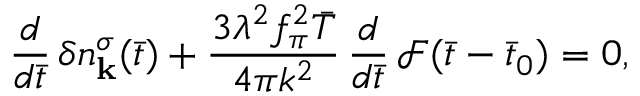Convert formula to latex. <formula><loc_0><loc_0><loc_500><loc_500>\frac { d } { d \bar { t } } \, \delta n _ { k } ^ { \sigma } ( \bar { t } ) + \frac { 3 \lambda ^ { 2 } f _ { \pi } ^ { 2 } \bar { T } } { 4 \pi k ^ { 2 } } \, \frac { d } { d \bar { t } } \, \mathcal { F } ( \bar { t } - \bar { t } _ { 0 } ) = 0 ,</formula> 